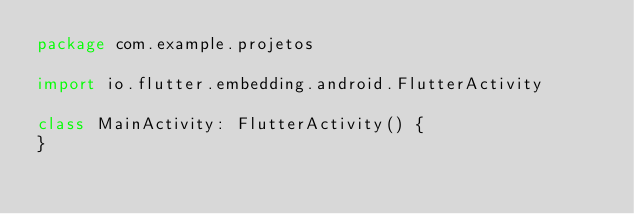Convert code to text. <code><loc_0><loc_0><loc_500><loc_500><_Kotlin_>package com.example.projetos

import io.flutter.embedding.android.FlutterActivity

class MainActivity: FlutterActivity() {
}
</code> 